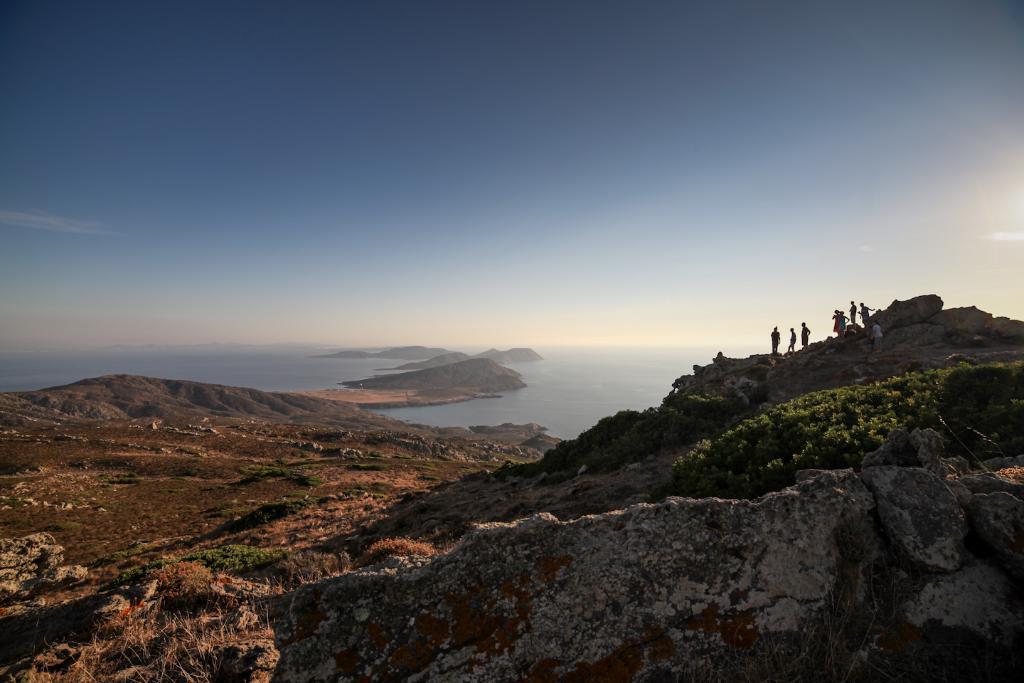In one or two sentences, can you explain what this image depicts? In this image at the bottom there are some rocks, mountains and some trees and there are a group of people standing. And in the background there is a river, and at the top there is sky. 